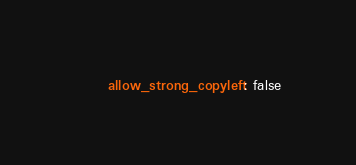Convert code to text. <code><loc_0><loc_0><loc_500><loc_500><_YAML_>      allow_strong_copyleft: false
</code> 